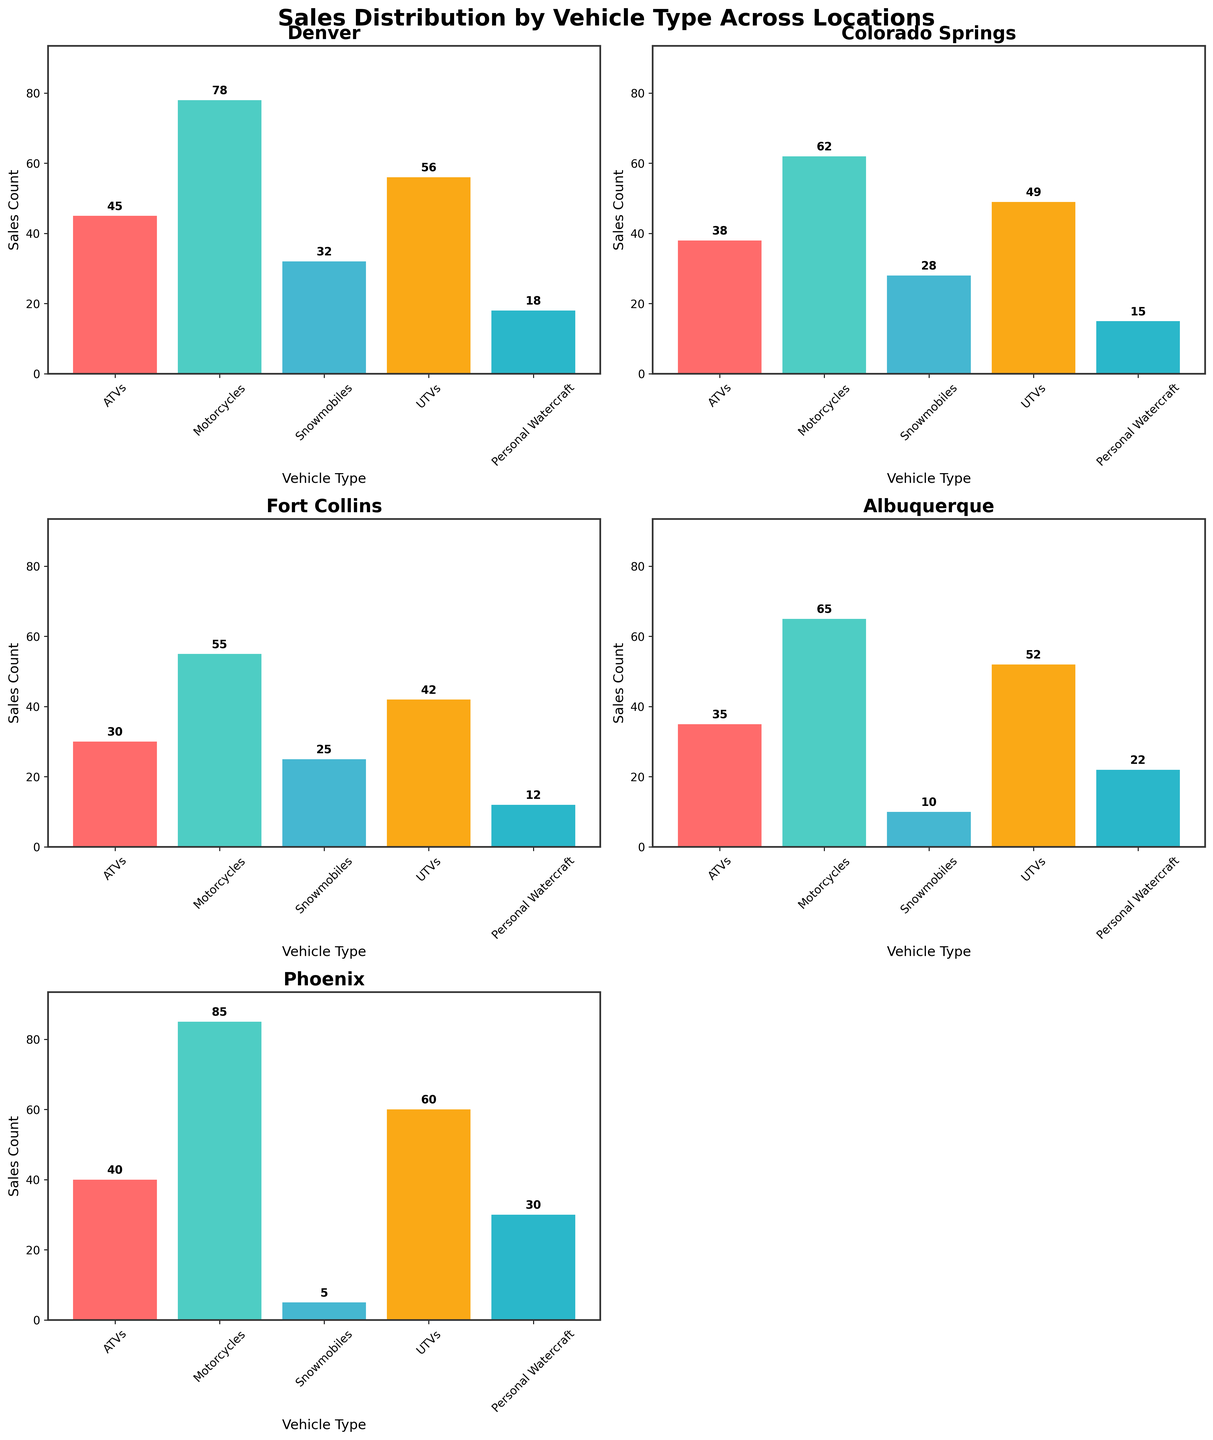What is the title of the figure? The title is usually located at the top of the figure. It summarizes the main topic of the visualization. In this case, the title is "Sales Distribution by Vehicle Type Across Locations".
Answer: Sales Distribution by Vehicle Type Across Locations Which location has the highest sales for Personal Watercraft? To find the highest sales for Personal Watercraft, we need to look at the bars corresponding to ‘Personal Watercraft’ in each subplot and identify the tallest one. In this case, Phoenix has the highest sales of Personal Watercraft with a count of 30.
Answer: Phoenix What are the different vehicle types shown in each subplot? The vehicle types are shown on the x-axis of each subplot. All the subplots use the same vehicle types, which are ATVs, Motorcycles, Snowmobiles, UTVs, and Personal Watercraft.
Answer: ATVs, Motorcycles, Snowmobiles, UTVs, Personal Watercraft Which location has the lowest total sales count? To determine the location with the lowest total sales count, we add up the sales counts for each vehicle type in each subplot and compare. Fort Collins has the lowest total sales count (30 + 55 + 25 + 42 + 12 = 164).
Answer: Fort Collins How do the sales of ATVs in Albuquerque compare to those in Colorado Springs? We compare the bars corresponding to ATVs in the Albuquerque and Colorado Springs subplots. Albuquerque has 35 sales while Colorado Springs has 38 sales.
Answer: 38 > 35 What is the difference in sales of Motorcycles between Denver and Phoenix? Subtract the sales count of Motorcycles in Denver from the sales count in Phoenix to find the difference. Denver has 78 and Phoenix has 85, so the difference is 85 - 78 = 7.
Answer: 7 What is the total sales count for Snowmobiles across all locations? To find the total sales count for Snowmobiles, add up the sales counts from each location: 32 (Denver) + 28 (Colorado Springs) + 25 (Fort Collins) + 10 (Albuquerque) + 5 (Phoenix) = 100.
Answer: 100 Which vehicle type has the most consistent sales distribution across all locations? To determine this, we look for the vehicle type with similar heights of bars across all subplots. Snowmobiles consistently have lower and fairly similar sales counts across all locations compared to others.
Answer: Snowmobiles What percentage of Denver's sales are motorcycles? First, sum the total sales for all vehicle types in Denver: 45 (ATVs) + 78 (Motorcycles) + 32 (Snowmobiles) + 56 (UTVs) + 18 (Personal Watercraft) = 229. Then, calculate the percentage: (78 / 229) * 100 = ~34%.
Answer: ~34% How do UTV sales in Fort Collins and Phoenix compare? Compare the UTV sales counts directly in the respective subplots: Fort Collins has 42 and Phoenix has 60. Thus, Phoenix has higher sales for UTVs compared to Fort Collins.
Answer: Phoenix > Fort Collins 